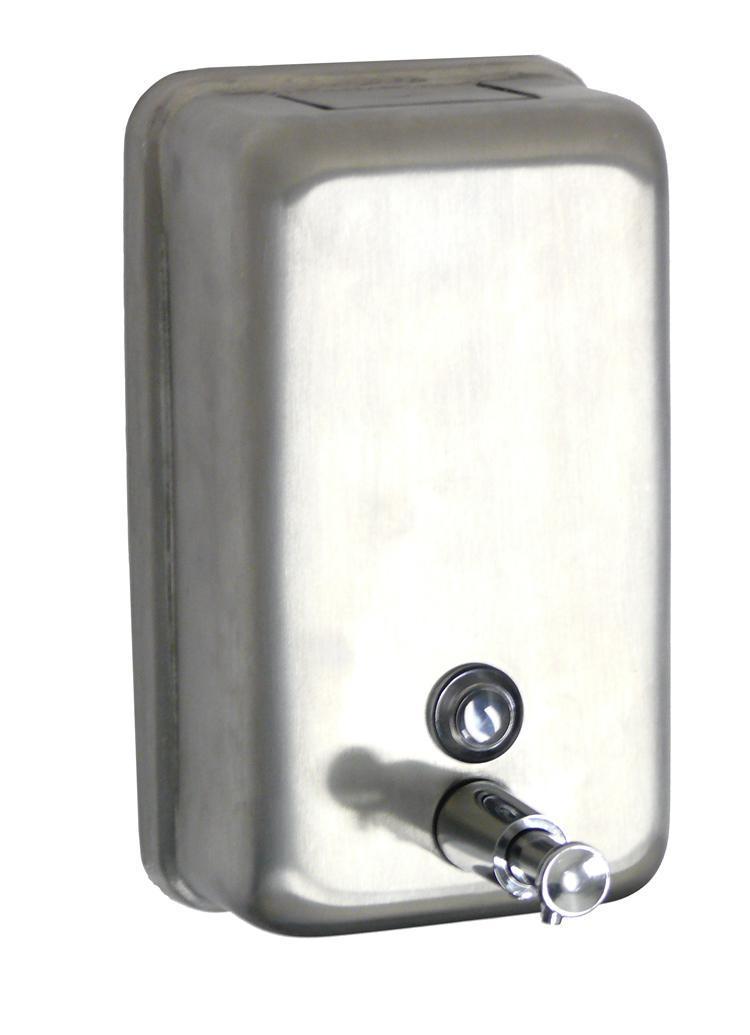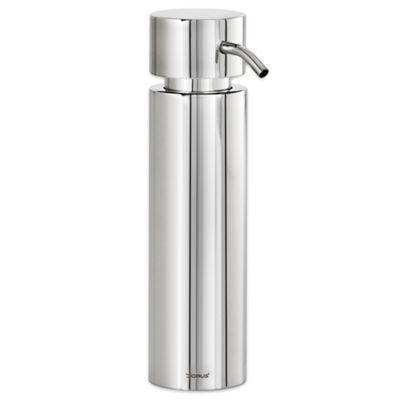The first image is the image on the left, the second image is the image on the right. Considering the images on both sides, is "The dispenser on the right image is tall and round." valid? Answer yes or no. Yes. The first image is the image on the left, the second image is the image on the right. Analyze the images presented: Is the assertion "The dispenser on the right is a cylinder with a narrow nozzle." valid? Answer yes or no. Yes. 